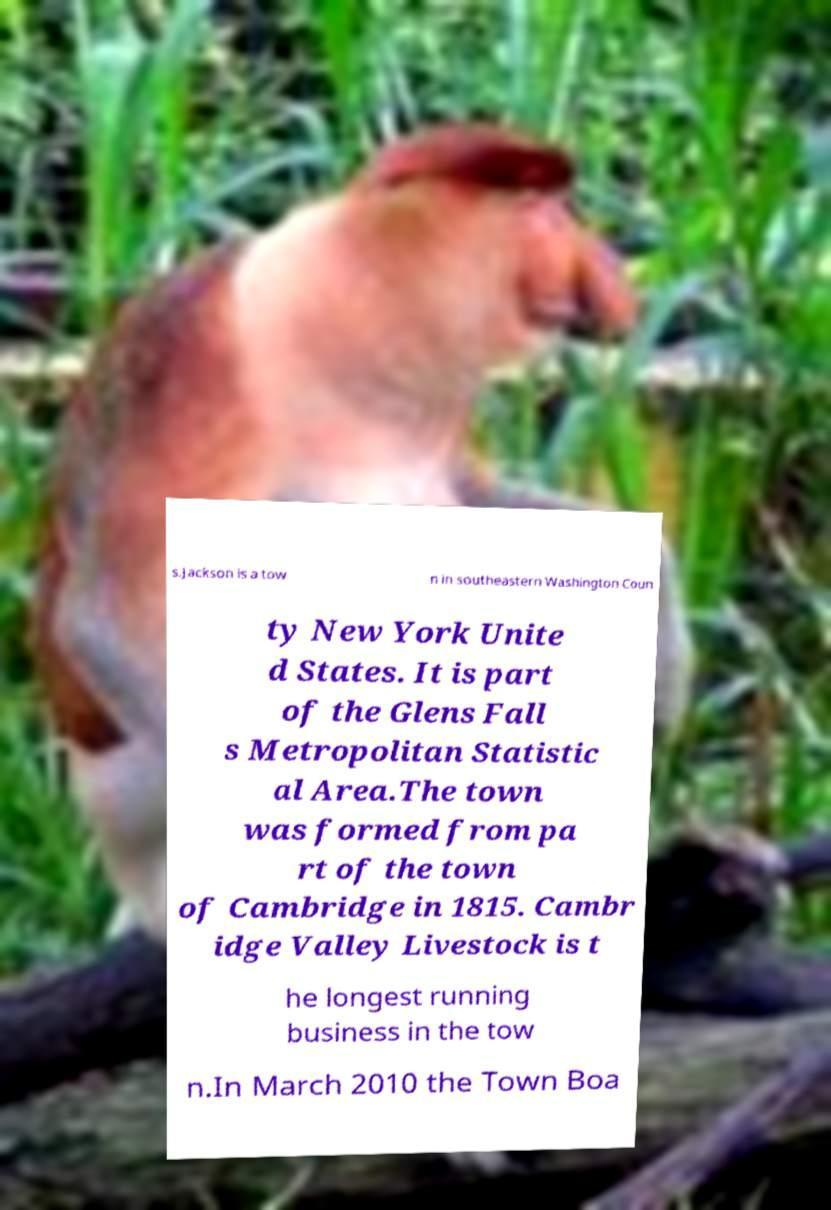I need the written content from this picture converted into text. Can you do that? s.Jackson is a tow n in southeastern Washington Coun ty New York Unite d States. It is part of the Glens Fall s Metropolitan Statistic al Area.The town was formed from pa rt of the town of Cambridge in 1815. Cambr idge Valley Livestock is t he longest running business in the tow n.In March 2010 the Town Boa 